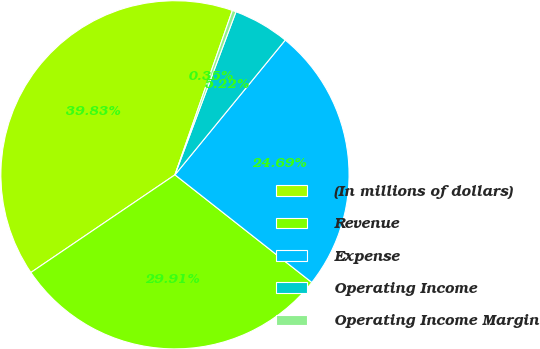<chart> <loc_0><loc_0><loc_500><loc_500><pie_chart><fcel>(In millions of dollars)<fcel>Revenue<fcel>Expense<fcel>Operating Income<fcel>Operating Income Margin<nl><fcel>39.83%<fcel>29.91%<fcel>24.69%<fcel>5.22%<fcel>0.35%<nl></chart> 